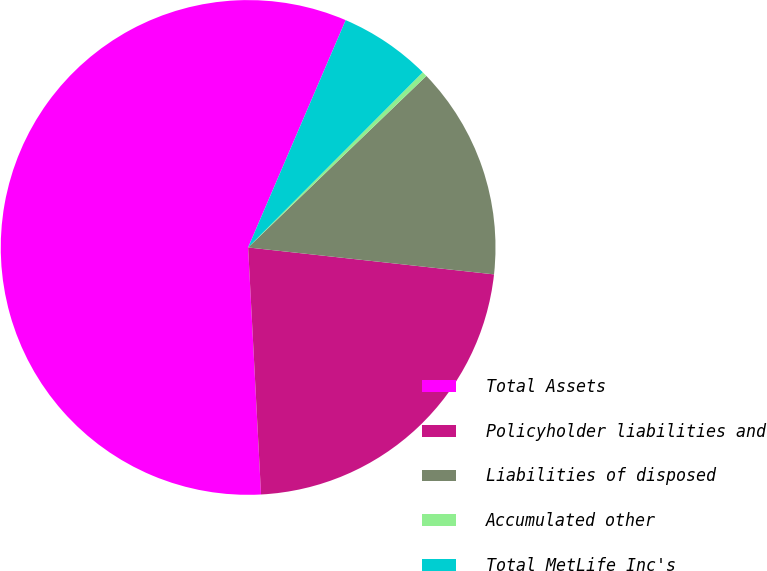Convert chart. <chart><loc_0><loc_0><loc_500><loc_500><pie_chart><fcel>Total Assets<fcel>Policyholder liabilities and<fcel>Liabilities of disposed<fcel>Accumulated other<fcel>Total MetLife Inc's<nl><fcel>57.28%<fcel>22.43%<fcel>13.93%<fcel>0.33%<fcel>6.02%<nl></chart> 